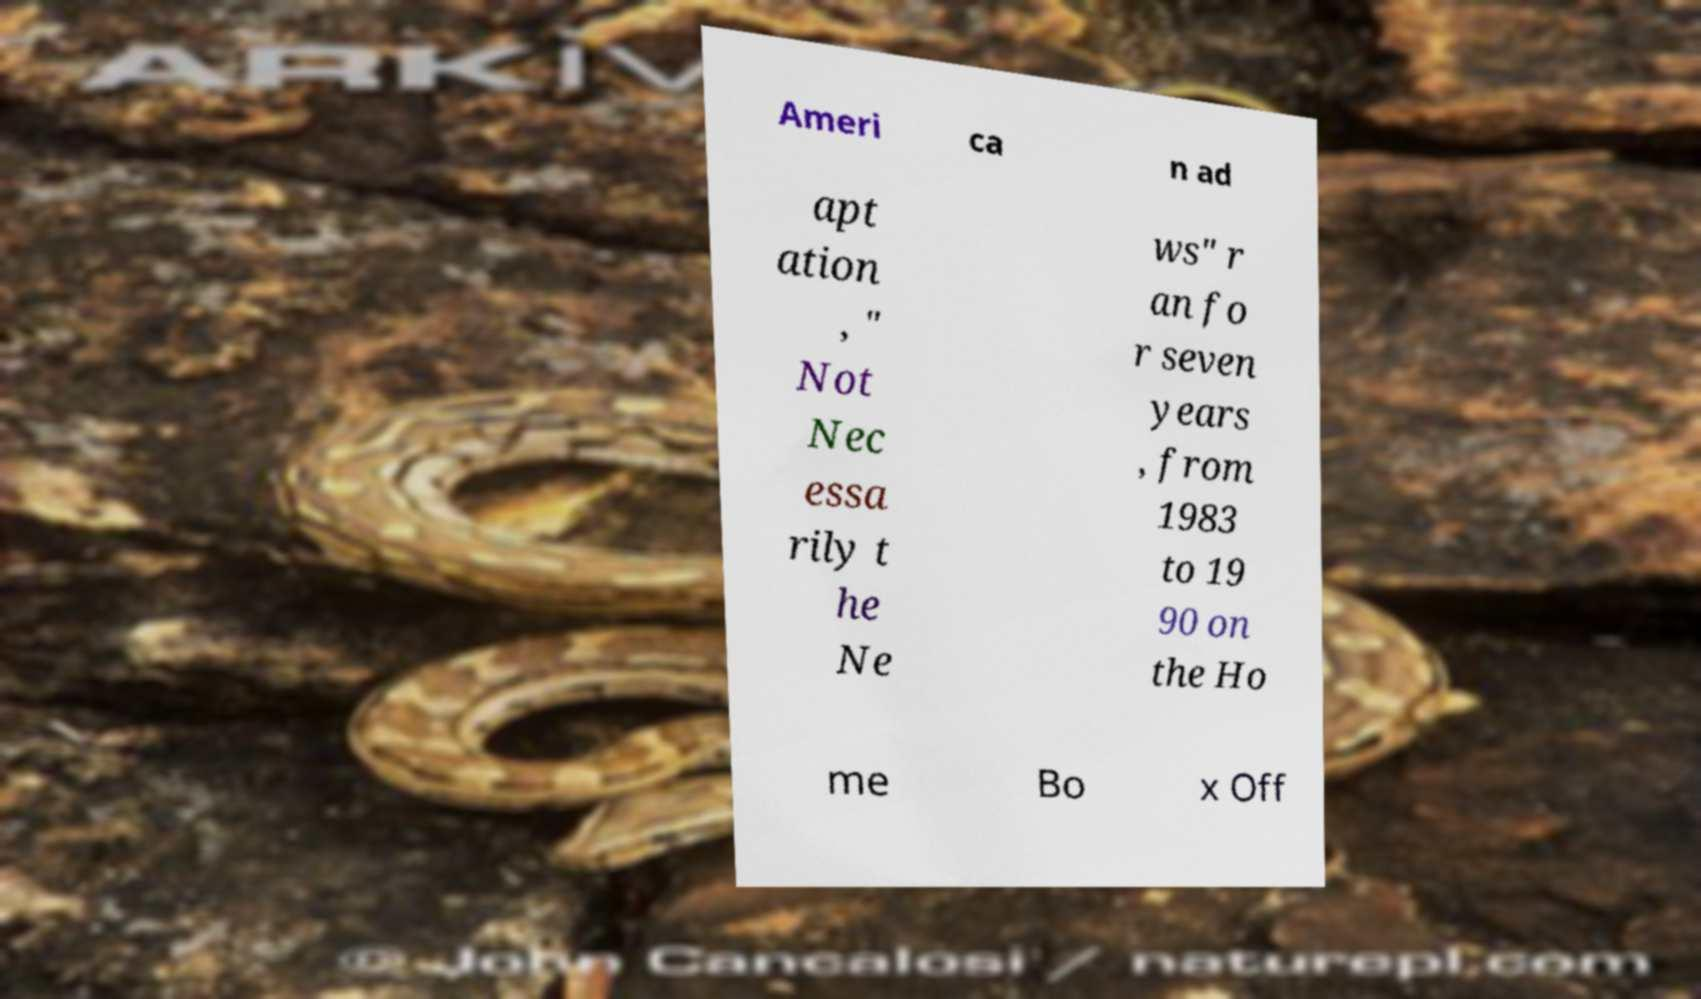Could you extract and type out the text from this image? Ameri ca n ad apt ation , " Not Nec essa rily t he Ne ws" r an fo r seven years , from 1983 to 19 90 on the Ho me Bo x Off 